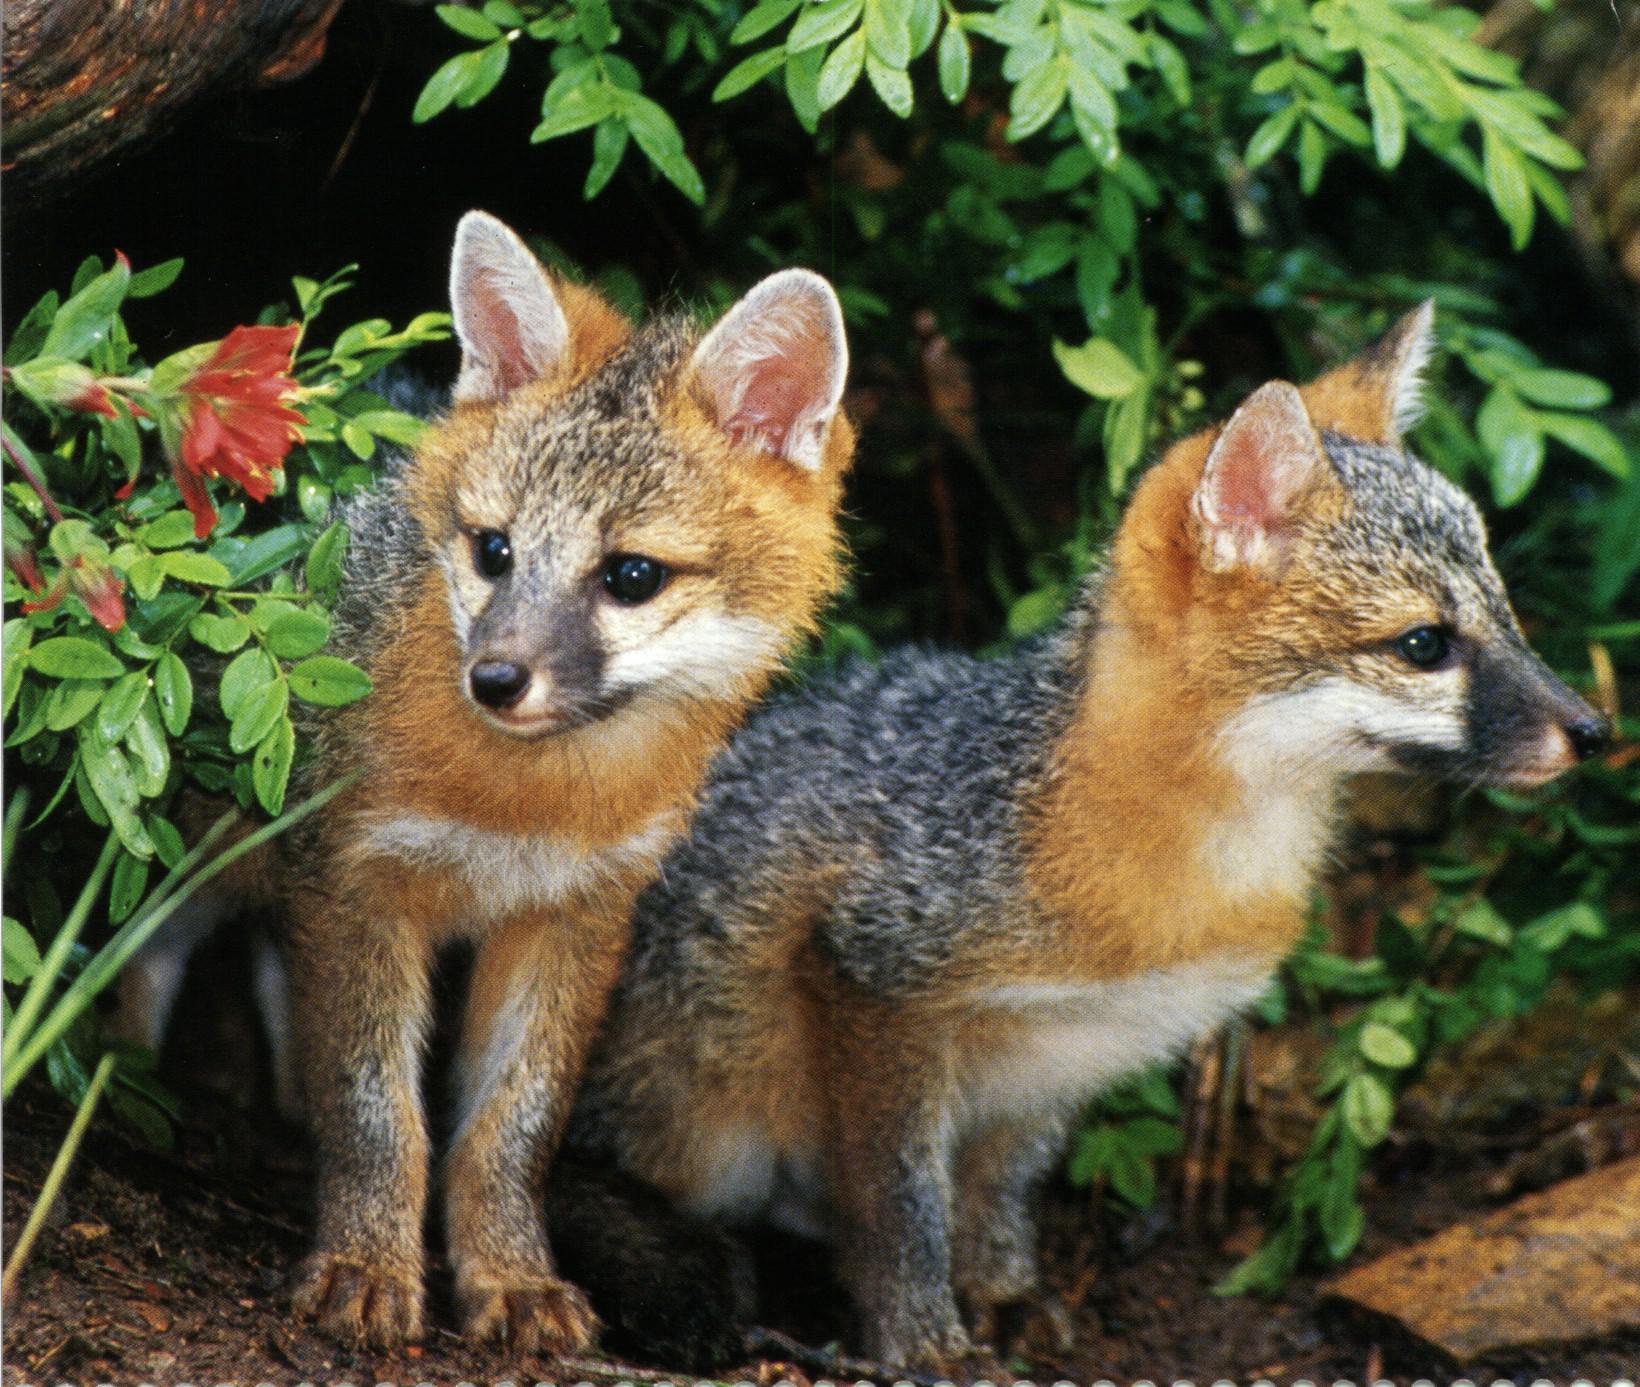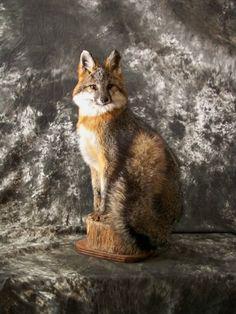The first image is the image on the left, the second image is the image on the right. Assess this claim about the two images: "The left image features one fox in a curled resting pose, and the right image features two foxes, with one reclining on the flat surface of a cut log section.". Correct or not? Answer yes or no. No. The first image is the image on the left, the second image is the image on the right. For the images shown, is this caption "There are two foxes in the image to the right, and one in the other image." true? Answer yes or no. No. 